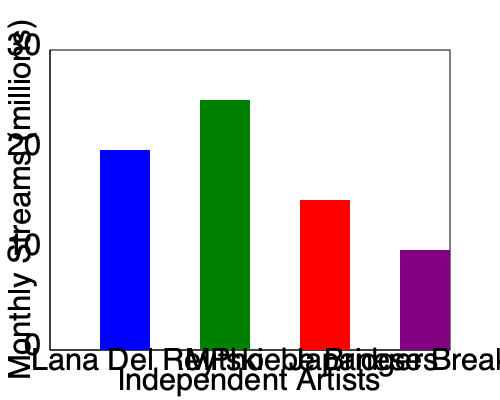Based on the bar graph showing monthly streaming statistics for independent artists, which artist has the highest number of monthly streams, and approximately how many million streams do they have? To answer this question, we need to analyze the bar graph:

1. The graph shows four independent artists: Lana Del Rey, Mitski, Phoebe Bridgers, and Japanese Breakfast.
2. The y-axis represents monthly streams in millions, with increments of 10 million.
3. Each bar's height corresponds to the number of monthly streams for that artist.
4. Comparing the heights of the bars:
   - Lana Del Rey's bar reaches between 20 and 30 million
   - Mitski's bar is the tallest, reaching slightly above 25 million
   - Phoebe Bridgers' bar is between 10 and 20 million
   - Japanese Breakfast's bar is at 10 million
5. Mitski has the tallest bar, indicating the highest number of monthly streams.
6. Mitski's bar ends just above the 25 million mark, so we can estimate it to be approximately 25 million streams per month.
Answer: Mitski, approximately 25 million streams 